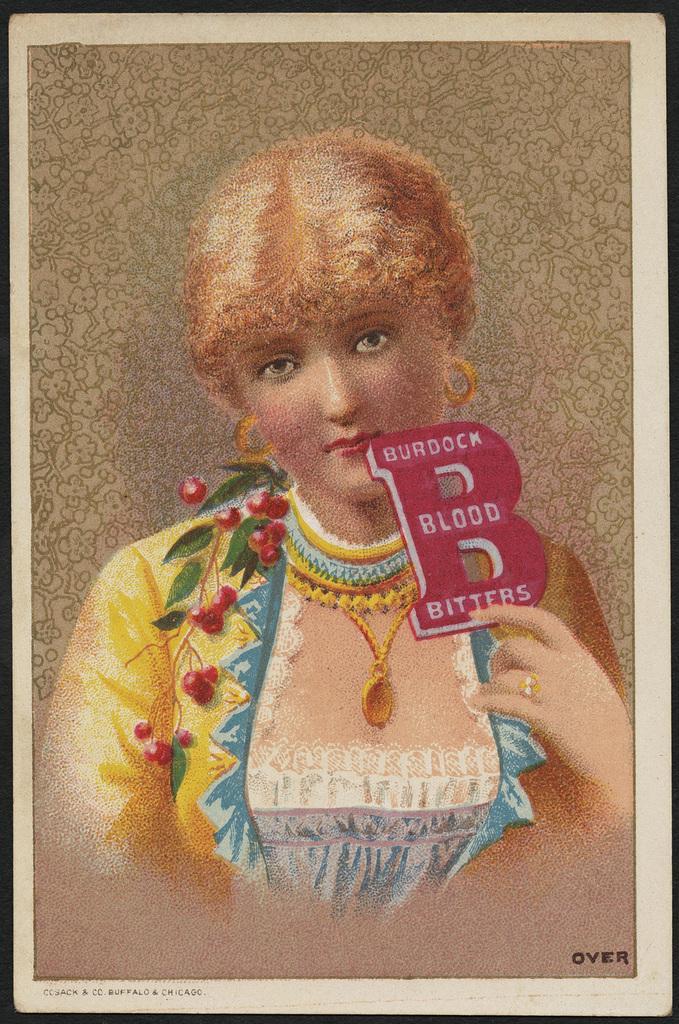Could you give a brief overview of what you see in this image? In the picture i can see a photo frame of the person and some text written on the photo frame. 